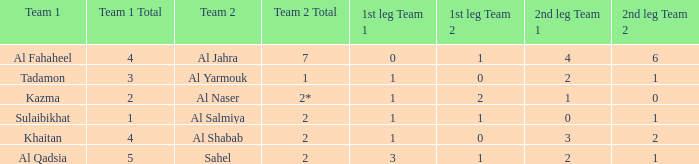What is the 1st leg of the match with a 2nd leg of 3-2? 1–0. 